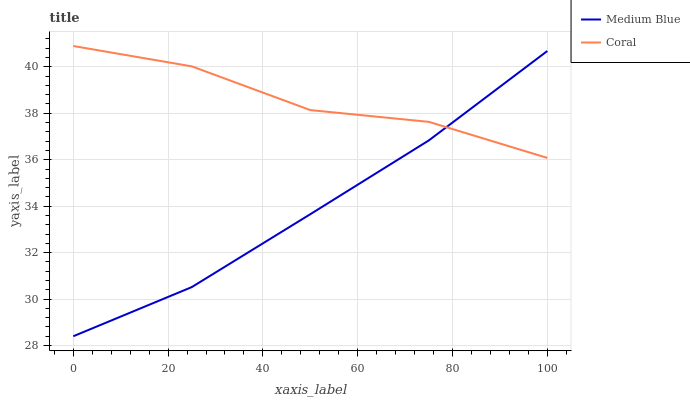Does Medium Blue have the minimum area under the curve?
Answer yes or no. Yes. Does Coral have the maximum area under the curve?
Answer yes or no. Yes. Does Medium Blue have the maximum area under the curve?
Answer yes or no. No. Is Medium Blue the smoothest?
Answer yes or no. Yes. Is Coral the roughest?
Answer yes or no. Yes. Is Medium Blue the roughest?
Answer yes or no. No. Does Medium Blue have the lowest value?
Answer yes or no. Yes. Does Coral have the highest value?
Answer yes or no. Yes. Does Medium Blue have the highest value?
Answer yes or no. No. Does Medium Blue intersect Coral?
Answer yes or no. Yes. Is Medium Blue less than Coral?
Answer yes or no. No. Is Medium Blue greater than Coral?
Answer yes or no. No. 